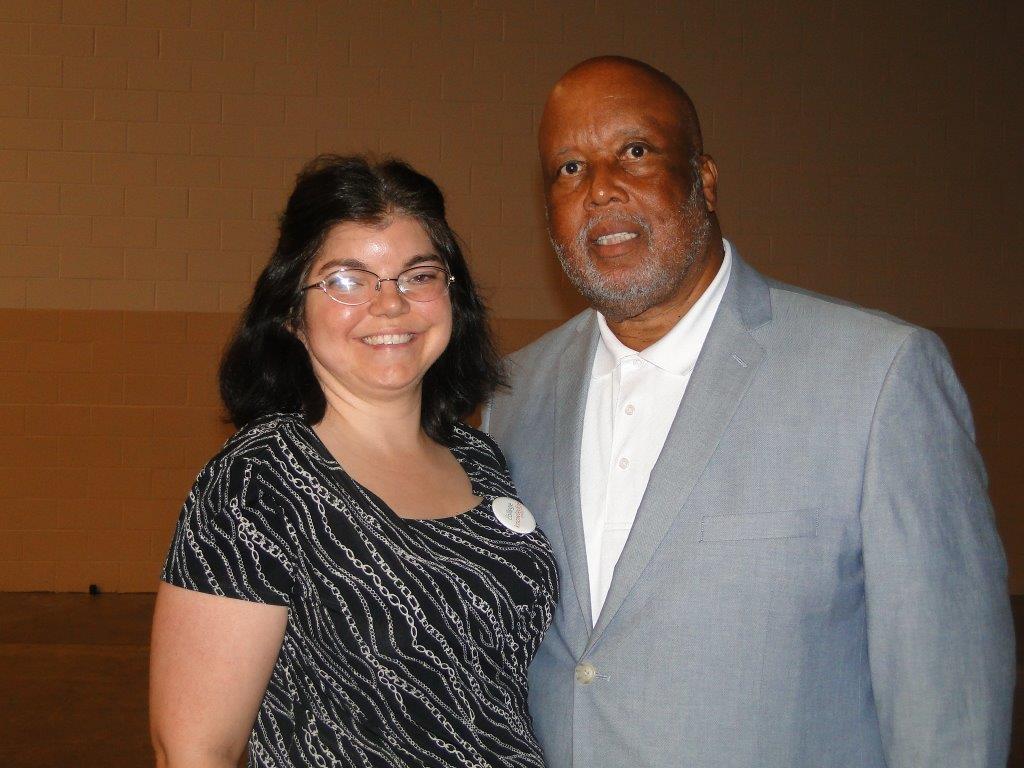Describe this image in one or two sentences. In the picture there is a man and a woman,both of them are smiling and posing for the photo and the man is wearing a grey blazer and white shirt. the woman is wearing white and black dress and in the background there is a wall. 